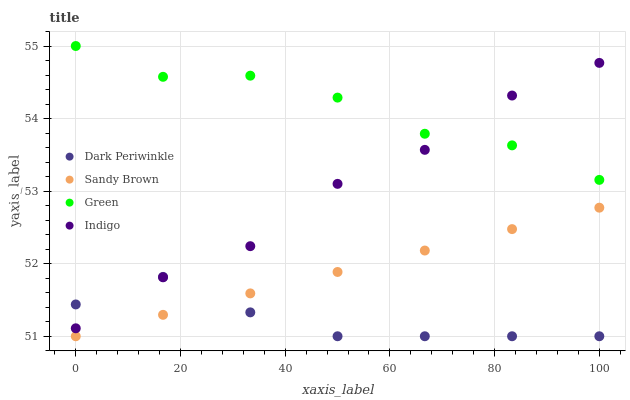Does Dark Periwinkle have the minimum area under the curve?
Answer yes or no. Yes. Does Green have the maximum area under the curve?
Answer yes or no. Yes. Does Sandy Brown have the minimum area under the curve?
Answer yes or no. No. Does Sandy Brown have the maximum area under the curve?
Answer yes or no. No. Is Sandy Brown the smoothest?
Answer yes or no. Yes. Is Indigo the roughest?
Answer yes or no. Yes. Is Dark Periwinkle the smoothest?
Answer yes or no. No. Is Dark Periwinkle the roughest?
Answer yes or no. No. Does Sandy Brown have the lowest value?
Answer yes or no. Yes. Does Indigo have the lowest value?
Answer yes or no. No. Does Green have the highest value?
Answer yes or no. Yes. Does Sandy Brown have the highest value?
Answer yes or no. No. Is Sandy Brown less than Indigo?
Answer yes or no. Yes. Is Green greater than Dark Periwinkle?
Answer yes or no. Yes. Does Dark Periwinkle intersect Sandy Brown?
Answer yes or no. Yes. Is Dark Periwinkle less than Sandy Brown?
Answer yes or no. No. Is Dark Periwinkle greater than Sandy Brown?
Answer yes or no. No. Does Sandy Brown intersect Indigo?
Answer yes or no. No. 